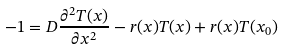<formula> <loc_0><loc_0><loc_500><loc_500>- 1 = D \frac { \partial ^ { 2 } T ( x ) } { \partial x ^ { 2 } } - r ( x ) T ( x ) + r ( x ) T ( x _ { 0 } )</formula> 